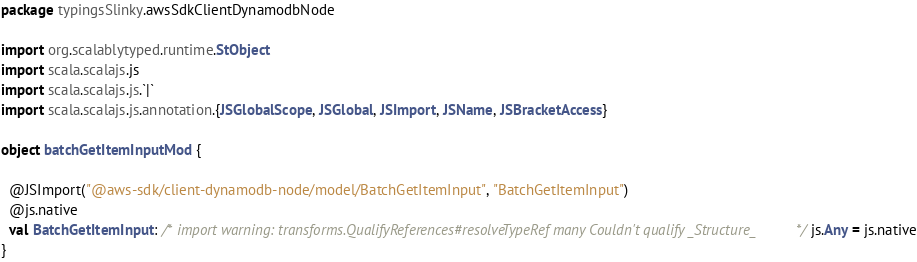<code> <loc_0><loc_0><loc_500><loc_500><_Scala_>package typingsSlinky.awsSdkClientDynamodbNode

import org.scalablytyped.runtime.StObject
import scala.scalajs.js
import scala.scalajs.js.`|`
import scala.scalajs.js.annotation.{JSGlobalScope, JSGlobal, JSImport, JSName, JSBracketAccess}

object batchGetItemInputMod {
  
  @JSImport("@aws-sdk/client-dynamodb-node/model/BatchGetItemInput", "BatchGetItemInput")
  @js.native
  val BatchGetItemInput: /* import warning: transforms.QualifyReferences#resolveTypeRef many Couldn't qualify _Structure_ */ js.Any = js.native
}
</code> 